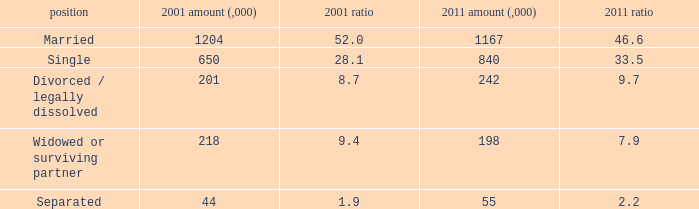What is the 2001 % for the status widowed or surviving partner? 9.4. 